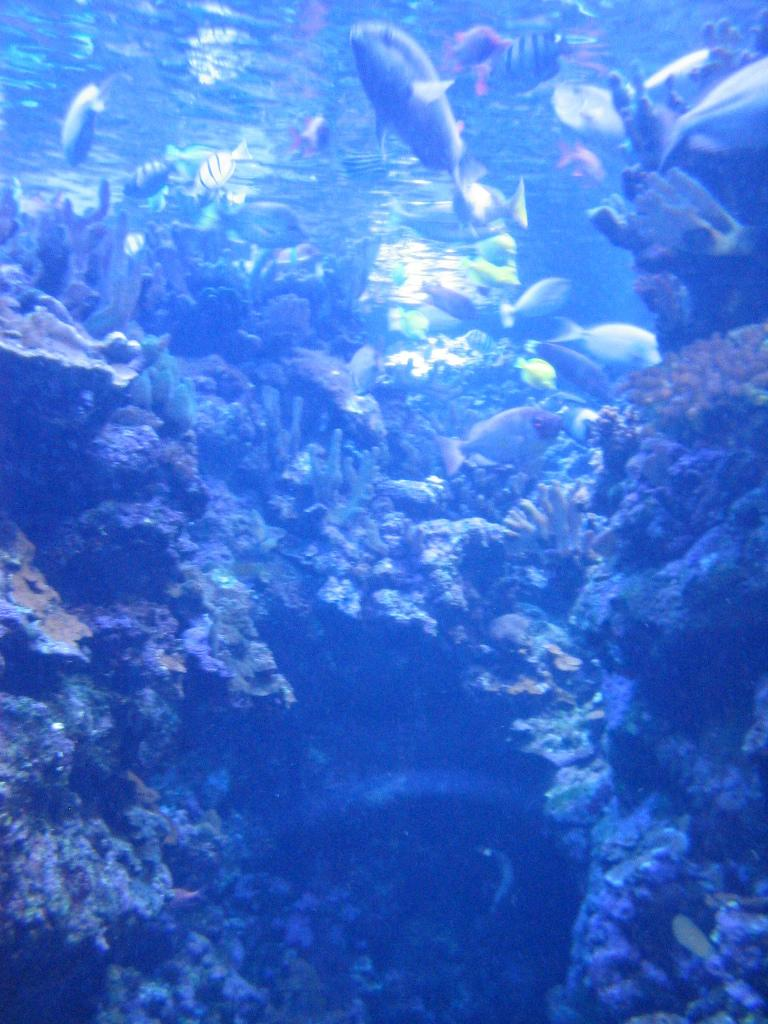What type of animals can be seen in the image? There are fishes in the image. What other objects or features can be seen in the image? There are corals in the image. Where are the fishes and corals located? The fishes and corals are underwater. What type of fruit can be seen growing on the corals in the image? There is no fruit, specifically quince, growing on the corals in the image. Corals are marine invertebrates and do not support plant growth. 